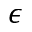<formula> <loc_0><loc_0><loc_500><loc_500>\epsilon</formula> 